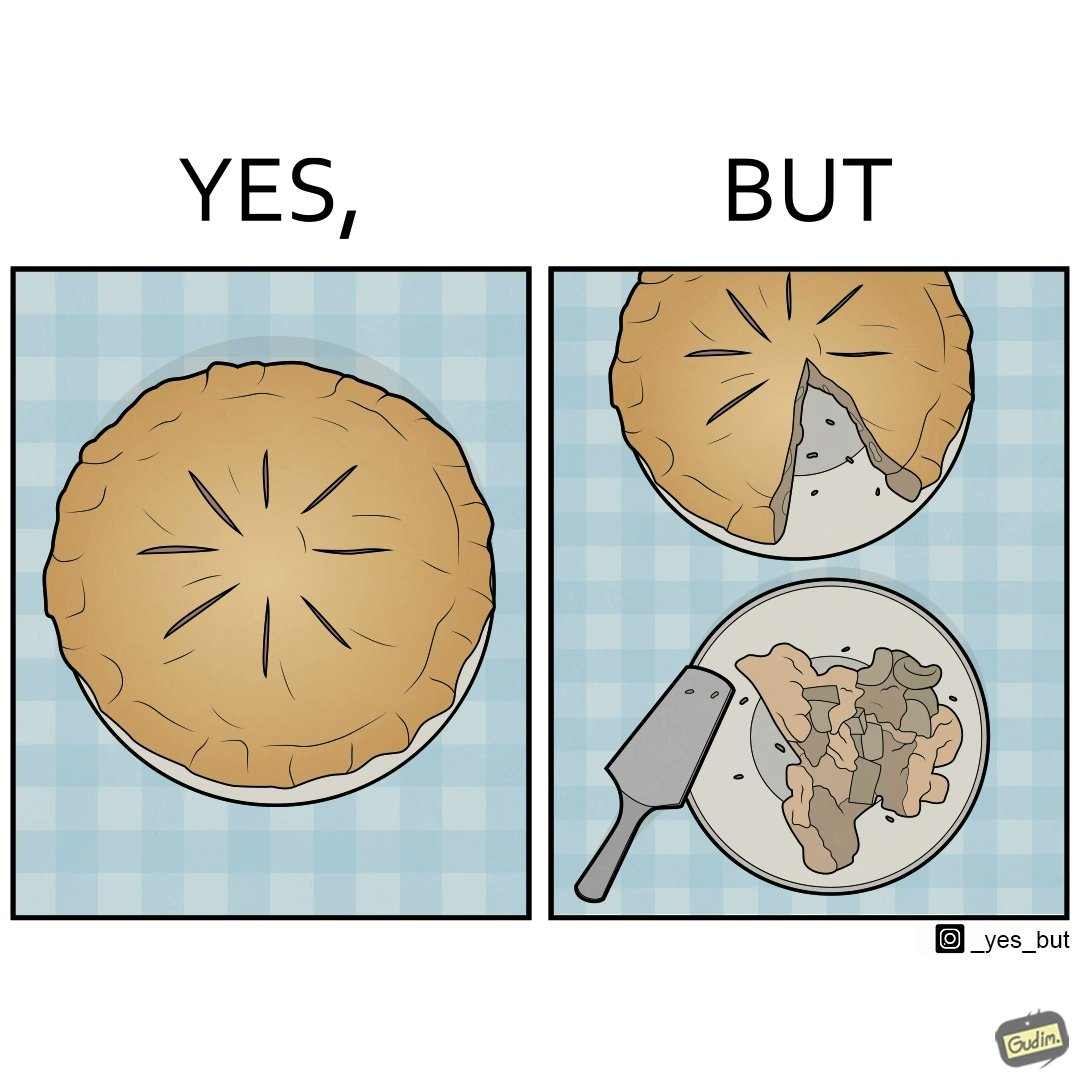Describe what you see in this image. The image is funny because why people like to get whole pies, they only end up eating a small portion of it wasting the rest of the pie. 